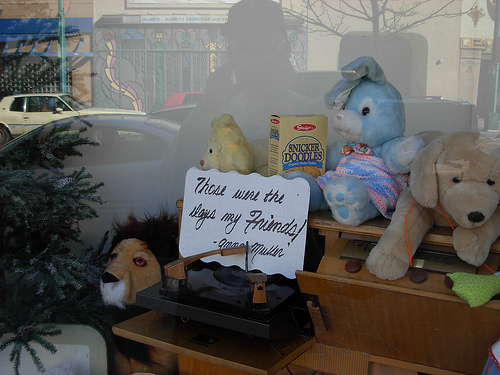<image>
Can you confirm if the snickerdoodle is to the left of the lamb? No. The snickerdoodle is not to the left of the lamb. From this viewpoint, they have a different horizontal relationship. 